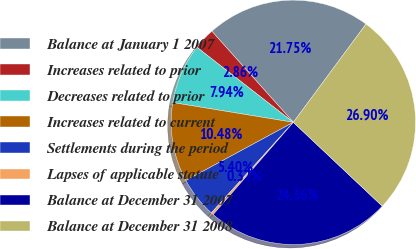<chart> <loc_0><loc_0><loc_500><loc_500><pie_chart><fcel>Balance at January 1 2007<fcel>Increases related to prior<fcel>Decreases related to prior<fcel>Increases related to current<fcel>Settlements during the period<fcel>Lapses of applicable statute<fcel>Balance at December 31 2007<fcel>Balance at December 31 2008<nl><fcel>21.75%<fcel>2.86%<fcel>7.94%<fcel>10.48%<fcel>5.4%<fcel>0.32%<fcel>24.36%<fcel>26.9%<nl></chart> 